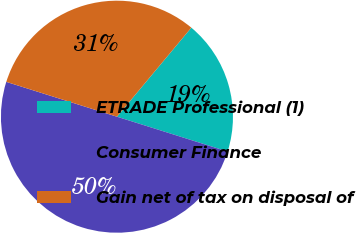Convert chart. <chart><loc_0><loc_0><loc_500><loc_500><pie_chart><fcel>ETRADE Professional (1)<fcel>Consumer Finance<fcel>Gain net of tax on disposal of<nl><fcel>18.78%<fcel>50.0%<fcel>31.22%<nl></chart> 